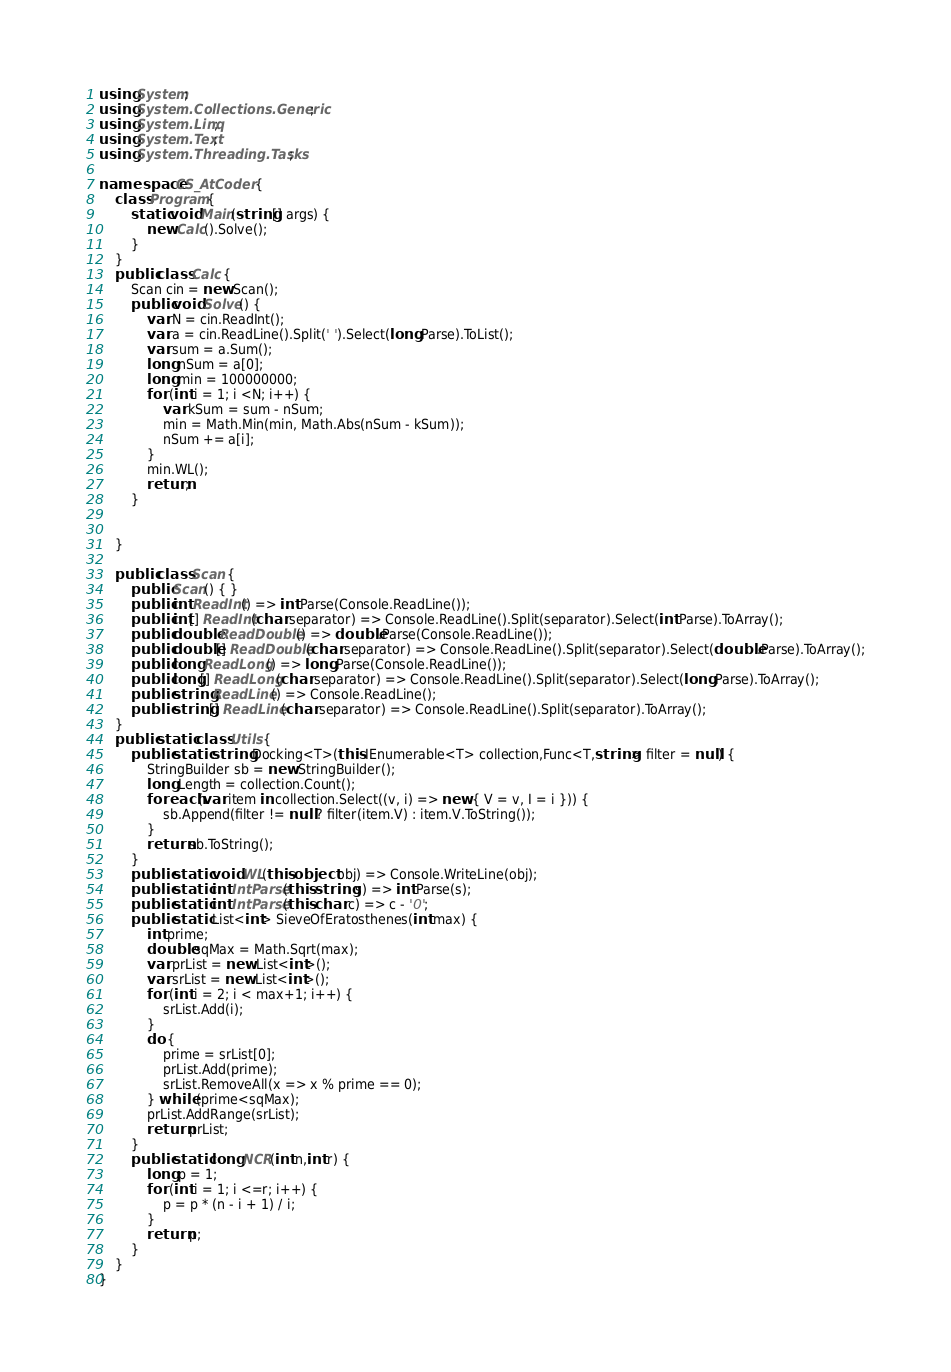<code> <loc_0><loc_0><loc_500><loc_500><_C#_>using System;
using System.Collections.Generic;
using System.Linq;
using System.Text;
using System.Threading.Tasks;

namespace CS_AtCoder {
	class Program {
		static void Main(string[] args) {
			new Calc().Solve();
		}
	}
	public class Calc {
		Scan cin = new Scan();
		public void Solve() {
			var N = cin.ReadInt();
			var a = cin.ReadLine().Split(' ').Select(long.Parse).ToList();
			var sum = a.Sum();
			long nSum = a[0];
			long min = 100000000;
			for (int i = 1; i <N; i++) {
				var kSum = sum - nSum;
				min = Math.Min(min, Math.Abs(nSum - kSum));
				nSum += a[i];
			}
			min.WL();
			return;
		}


	}

	public class Scan {
		public Scan() { }
		public int ReadInt() => int.Parse(Console.ReadLine());
		public int[] ReadInt(char separator) => Console.ReadLine().Split(separator).Select(int.Parse).ToArray();
		public double ReadDouble() => double.Parse(Console.ReadLine());
		public double[] ReadDouble(char separator) => Console.ReadLine().Split(separator).Select(double.Parse).ToArray();
		public long ReadLong() => long.Parse(Console.ReadLine());
		public long[] ReadLong(char separator) => Console.ReadLine().Split(separator).Select(long.Parse).ToArray();
		public string ReadLine() => Console.ReadLine();
		public string[] ReadLine(char separator) => Console.ReadLine().Split(separator).ToArray();
	}
	public static class Utils {
		public static string Docking<T>(this IEnumerable<T> collection,Func<T,string> filter = null) {
			StringBuilder sb = new StringBuilder();
			long Length = collection.Count();
			foreach (var item in collection.Select((v, i) => new { V = v, I = i })) {
				sb.Append(filter != null ? filter(item.V) : item.V.ToString());
			}
			return sb.ToString();
		}
		public static void WL(this object obj) => Console.WriteLine(obj);
		public static int IntParse(this string s) => int.Parse(s);
		public static int IntParse(this char c) => c - '0';
		public static List<int> SieveOfEratosthenes(int max) {
			int prime;
			double sqMax = Math.Sqrt(max);
			var prList = new List<int>();
			var srList = new List<int>();
			for (int i = 2; i < max+1; i++) {
				srList.Add(i);
			}
			do {
				prime = srList[0];
				prList.Add(prime);
				srList.RemoveAll(x => x % prime == 0);
			} while (prime<sqMax);
			prList.AddRange(srList);
			return prList;
		}
		public static long NCR(int n,int r) {
			long p = 1;
			for (int i = 1; i <=r; i++) {
				p = p * (n - i + 1) / i;
			}
			return p;
		}
	}
}
</code> 